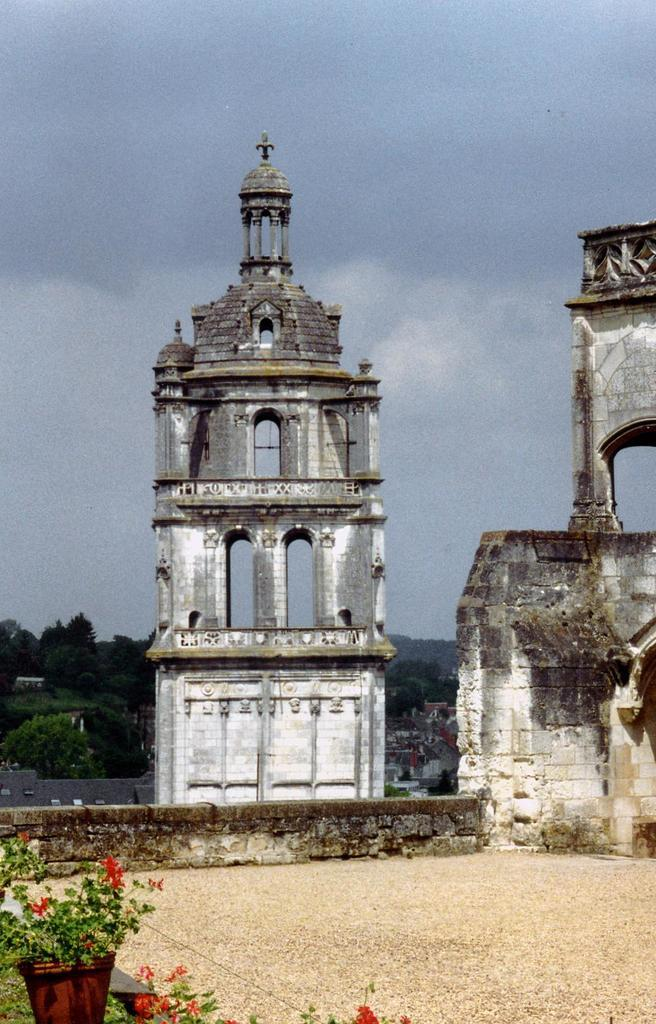What structures are present in the image? There are towers in the image. What objects related to plants can be seen in the image? There are flower pots in the image. What part of the natural environment is visible in the image? The sky is visible in the image. What type of wrench is being used to fix the tower in the image? There is no wrench present in the image, and the towers do not appear to be in need of repair. 